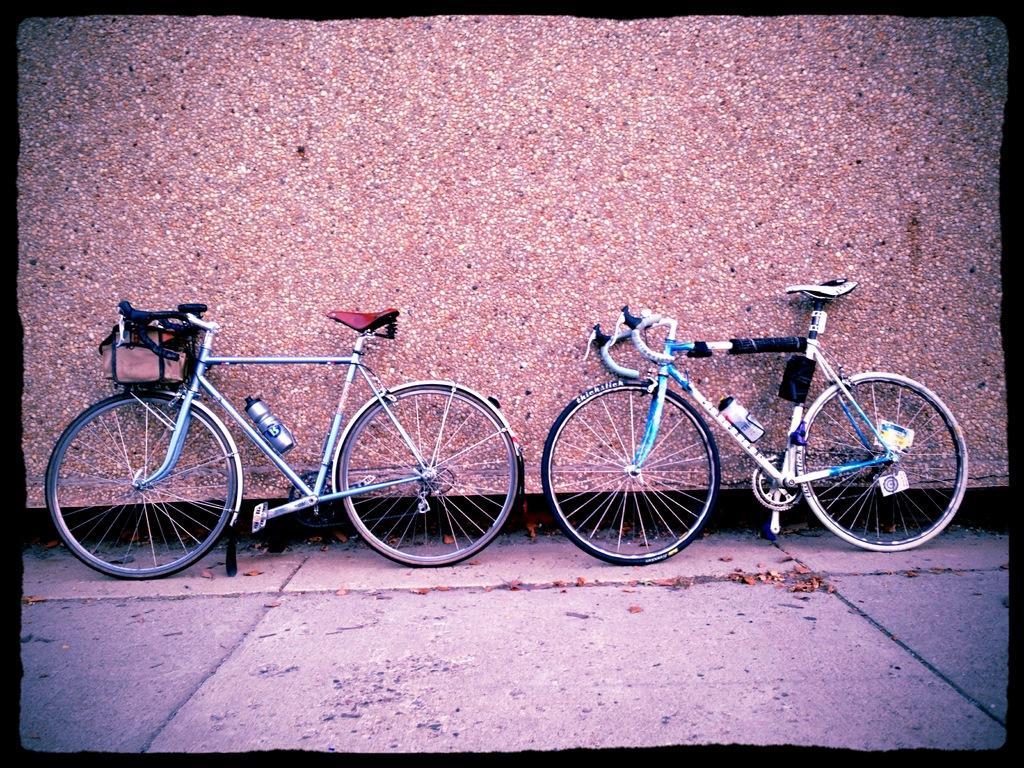How would you summarize this image in a sentence or two? In this image I can see two bicycles parked behind them I can see a wall with stones. 